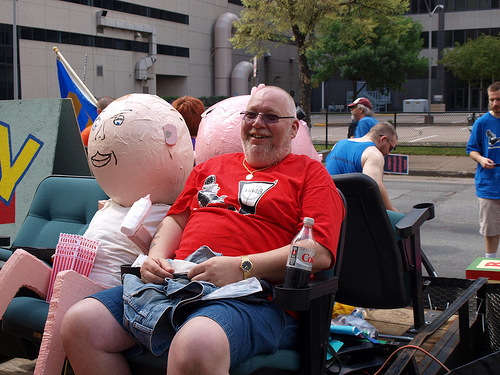<image>
Can you confirm if the doll is to the right of the man? Yes. From this viewpoint, the doll is positioned to the right side relative to the man. 